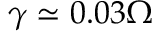Convert formula to latex. <formula><loc_0><loc_0><loc_500><loc_500>\gamma \simeq 0 . 0 3 \Omega</formula> 